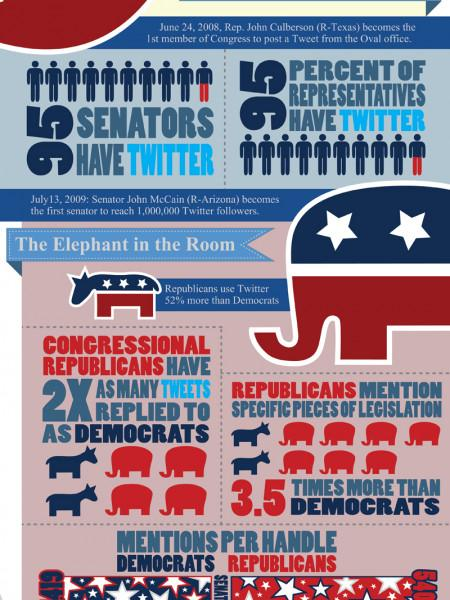Mention a couple of crucial points in this snapshot. According to a recent survey, only 5% of US Senators do not have a Twitter account. Republicans generate significantly more tweets related to legislation compared to Democrats, with a 3.5 times higher frequency of such posts. According to recent statistics, only 5% of US representatives do not have a Twitter account. 